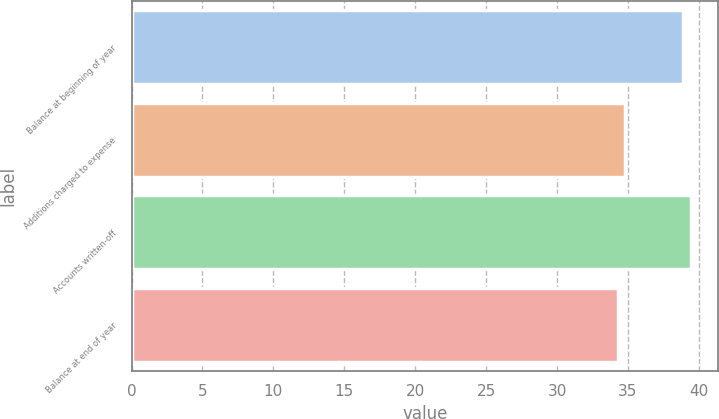<chart> <loc_0><loc_0><loc_500><loc_500><bar_chart><fcel>Balance at beginning of year<fcel>Additions charged to expense<fcel>Accounts written-off<fcel>Balance at end of year<nl><fcel>38.9<fcel>34.81<fcel>39.41<fcel>34.3<nl></chart> 